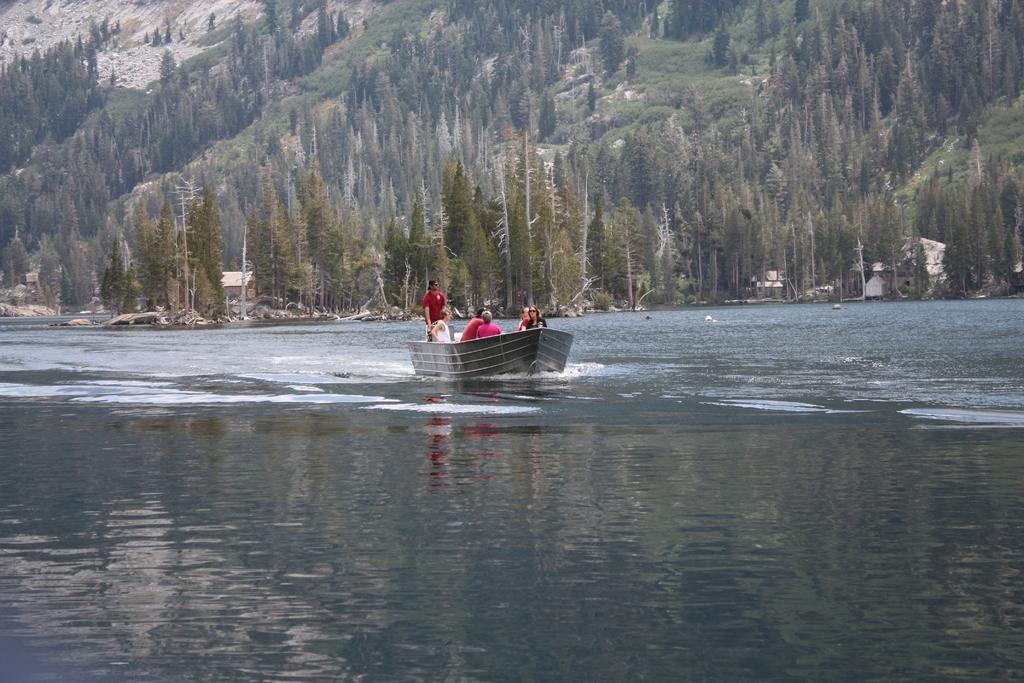Can you describe this image briefly? In this image we can see a group of people sitting in a boat placed in the water. One person wearing a red t shirt is standing. In the background, we can see a group of trees, buildings and mountains. 